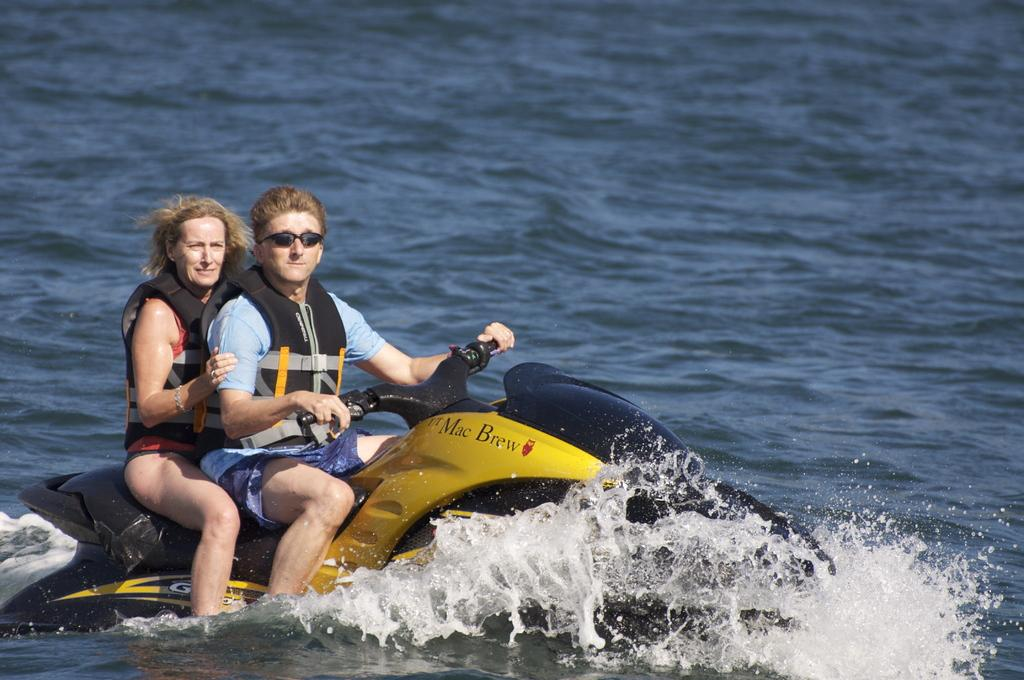<image>
Summarize the visual content of the image. 2 people are riding in the ocean on a Jetski that says Mac Brew. 